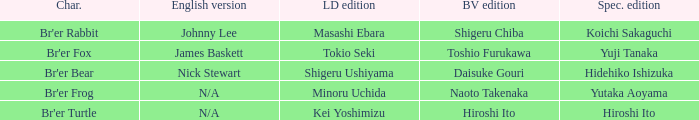What is the special edition for the english version of james baskett? Yuji Tanaka. 